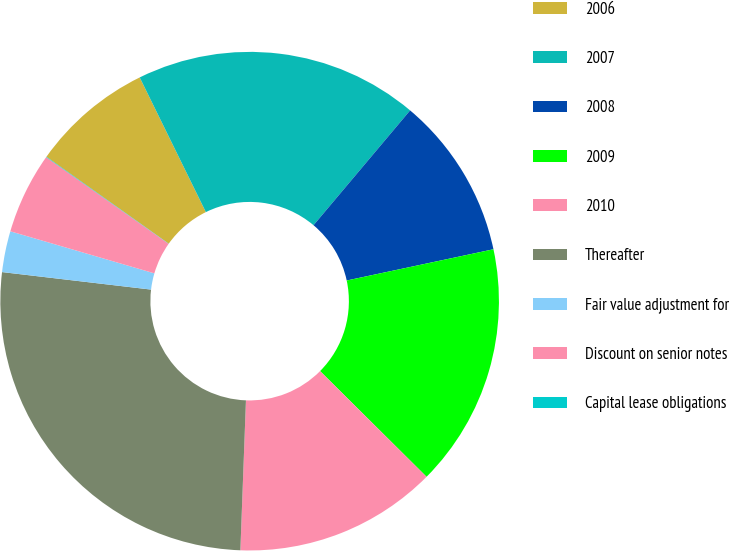Convert chart to OTSL. <chart><loc_0><loc_0><loc_500><loc_500><pie_chart><fcel>2006<fcel>2007<fcel>2008<fcel>2009<fcel>2010<fcel>Thereafter<fcel>Fair value adjustment for<fcel>Discount on senior notes<fcel>Capital lease obligations<nl><fcel>7.9%<fcel>18.4%<fcel>10.53%<fcel>15.78%<fcel>13.15%<fcel>26.27%<fcel>2.66%<fcel>5.28%<fcel>0.03%<nl></chart> 